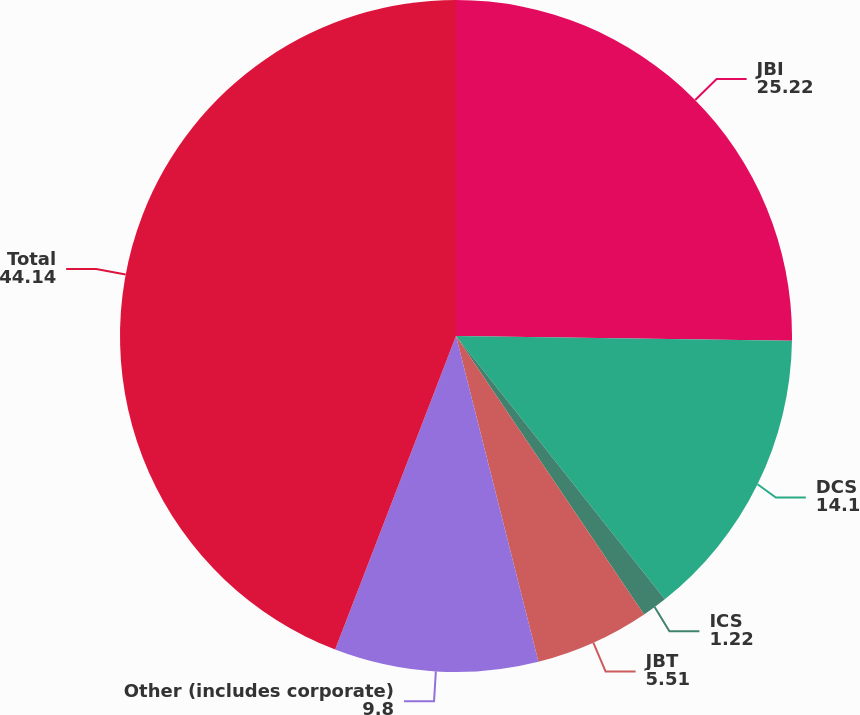<chart> <loc_0><loc_0><loc_500><loc_500><pie_chart><fcel>JBI<fcel>DCS<fcel>ICS<fcel>JBT<fcel>Other (includes corporate)<fcel>Total<nl><fcel>25.22%<fcel>14.1%<fcel>1.22%<fcel>5.51%<fcel>9.8%<fcel>44.14%<nl></chart> 